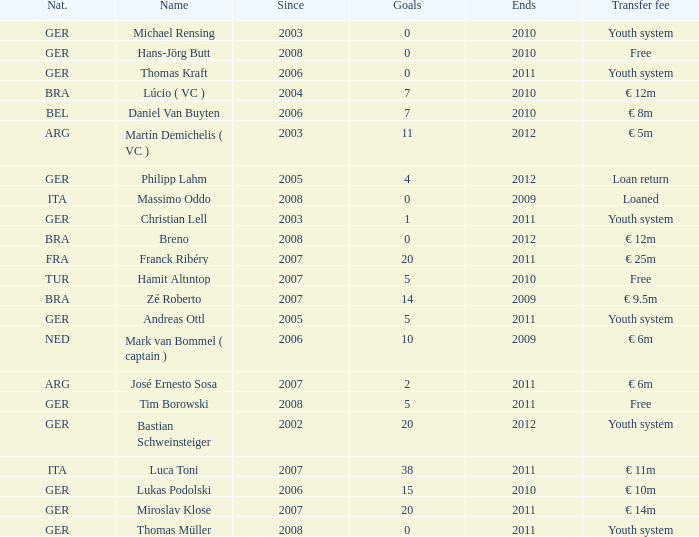What is the total number of ends after 2006 with a nationality of ita and 0 goals? 0.0. 